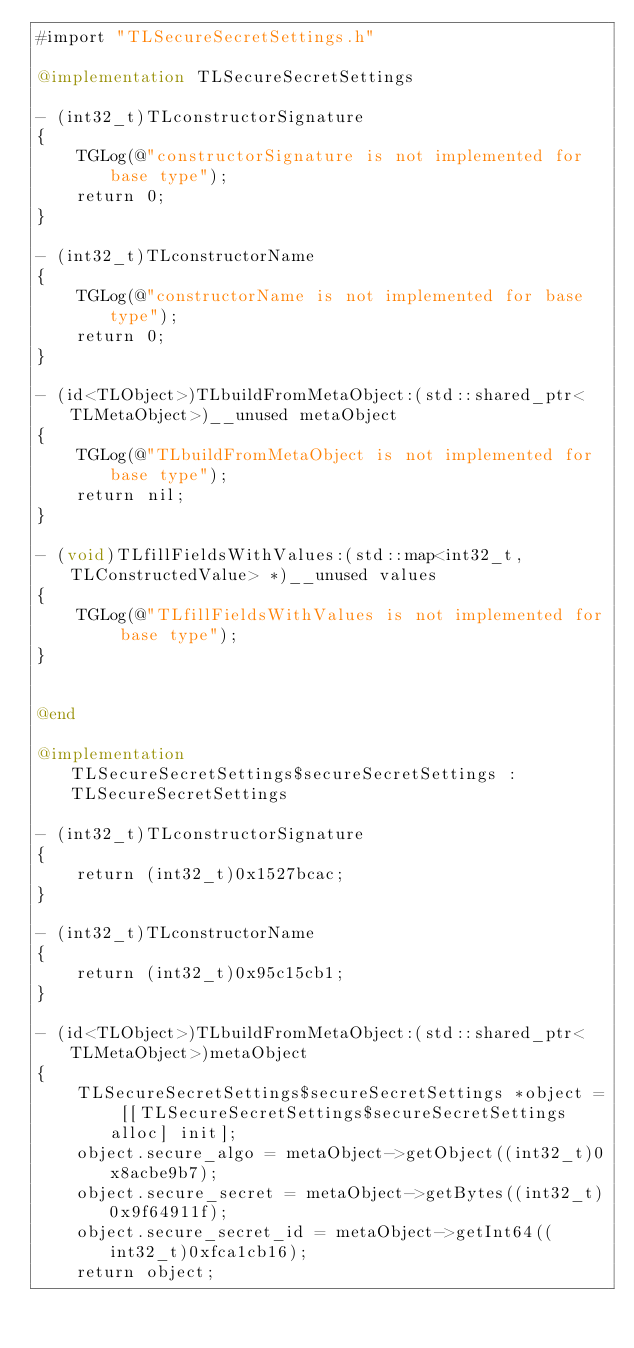Convert code to text. <code><loc_0><loc_0><loc_500><loc_500><_ObjectiveC_>#import "TLSecureSecretSettings.h"

@implementation TLSecureSecretSettings

- (int32_t)TLconstructorSignature
{
    TGLog(@"constructorSignature is not implemented for base type");
    return 0;
}

- (int32_t)TLconstructorName
{
    TGLog(@"constructorName is not implemented for base type");
    return 0;
}

- (id<TLObject>)TLbuildFromMetaObject:(std::shared_ptr<TLMetaObject>)__unused metaObject
{
    TGLog(@"TLbuildFromMetaObject is not implemented for base type");
    return nil;
}

- (void)TLfillFieldsWithValues:(std::map<int32_t, TLConstructedValue> *)__unused values
{
    TGLog(@"TLfillFieldsWithValues is not implemented for base type");
}


@end

@implementation TLSecureSecretSettings$secureSecretSettings : TLSecureSecretSettings

- (int32_t)TLconstructorSignature
{
    return (int32_t)0x1527bcac;
}

- (int32_t)TLconstructorName
{
    return (int32_t)0x95c15cb1;
}

- (id<TLObject>)TLbuildFromMetaObject:(std::shared_ptr<TLMetaObject>)metaObject
{
    TLSecureSecretSettings$secureSecretSettings *object = [[TLSecureSecretSettings$secureSecretSettings alloc] init];
    object.secure_algo = metaObject->getObject((int32_t)0x8acbe9b7);
    object.secure_secret = metaObject->getBytes((int32_t)0x9f64911f);
    object.secure_secret_id = metaObject->getInt64((int32_t)0xfca1cb16);
    return object;</code> 